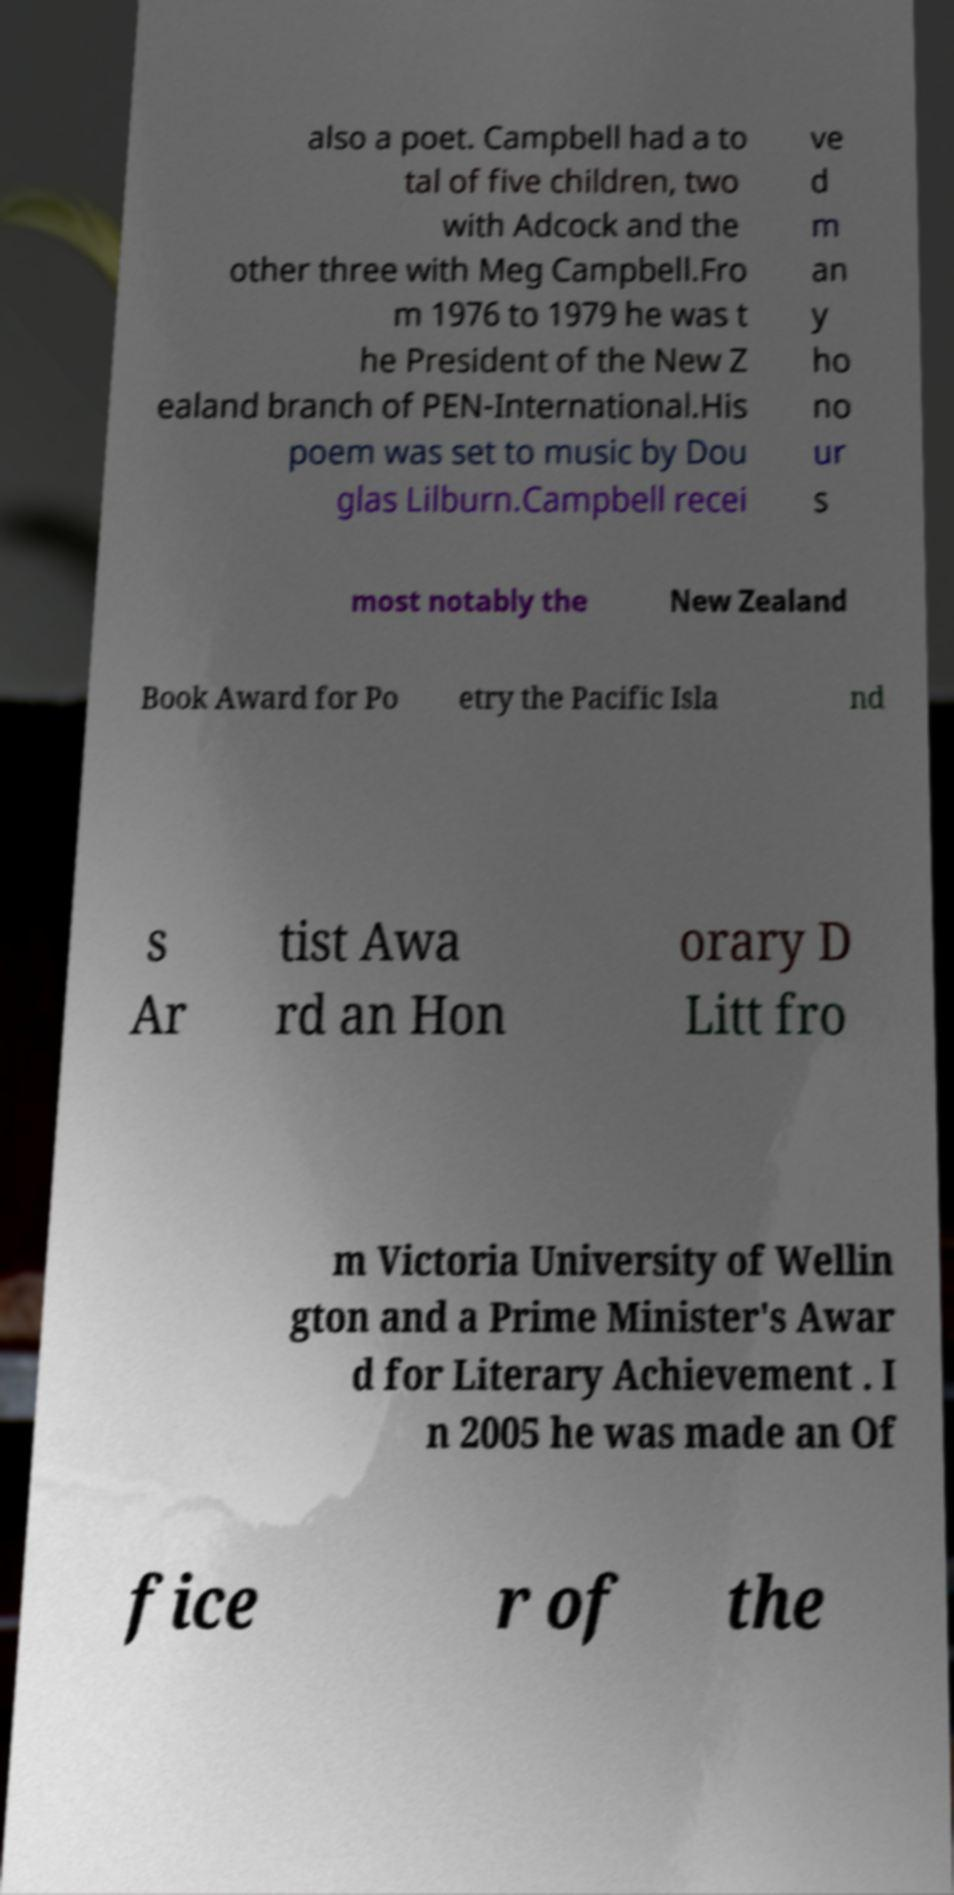For documentation purposes, I need the text within this image transcribed. Could you provide that? also a poet. Campbell had a to tal of five children, two with Adcock and the other three with Meg Campbell.Fro m 1976 to 1979 he was t he President of the New Z ealand branch of PEN-International.His poem was set to music by Dou glas Lilburn.Campbell recei ve d m an y ho no ur s most notably the New Zealand Book Award for Po etry the Pacific Isla nd s Ar tist Awa rd an Hon orary D Litt fro m Victoria University of Wellin gton and a Prime Minister's Awar d for Literary Achievement . I n 2005 he was made an Of fice r of the 